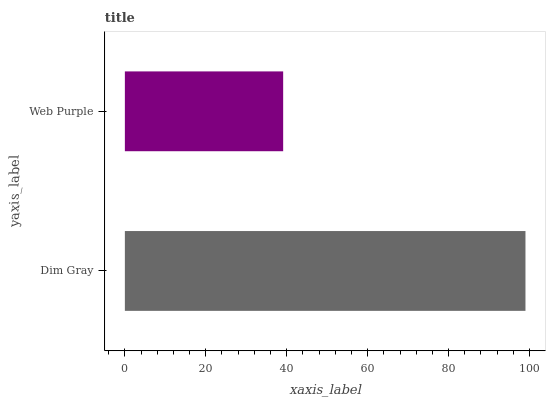Is Web Purple the minimum?
Answer yes or no. Yes. Is Dim Gray the maximum?
Answer yes or no. Yes. Is Web Purple the maximum?
Answer yes or no. No. Is Dim Gray greater than Web Purple?
Answer yes or no. Yes. Is Web Purple less than Dim Gray?
Answer yes or no. Yes. Is Web Purple greater than Dim Gray?
Answer yes or no. No. Is Dim Gray less than Web Purple?
Answer yes or no. No. Is Dim Gray the high median?
Answer yes or no. Yes. Is Web Purple the low median?
Answer yes or no. Yes. Is Web Purple the high median?
Answer yes or no. No. Is Dim Gray the low median?
Answer yes or no. No. 